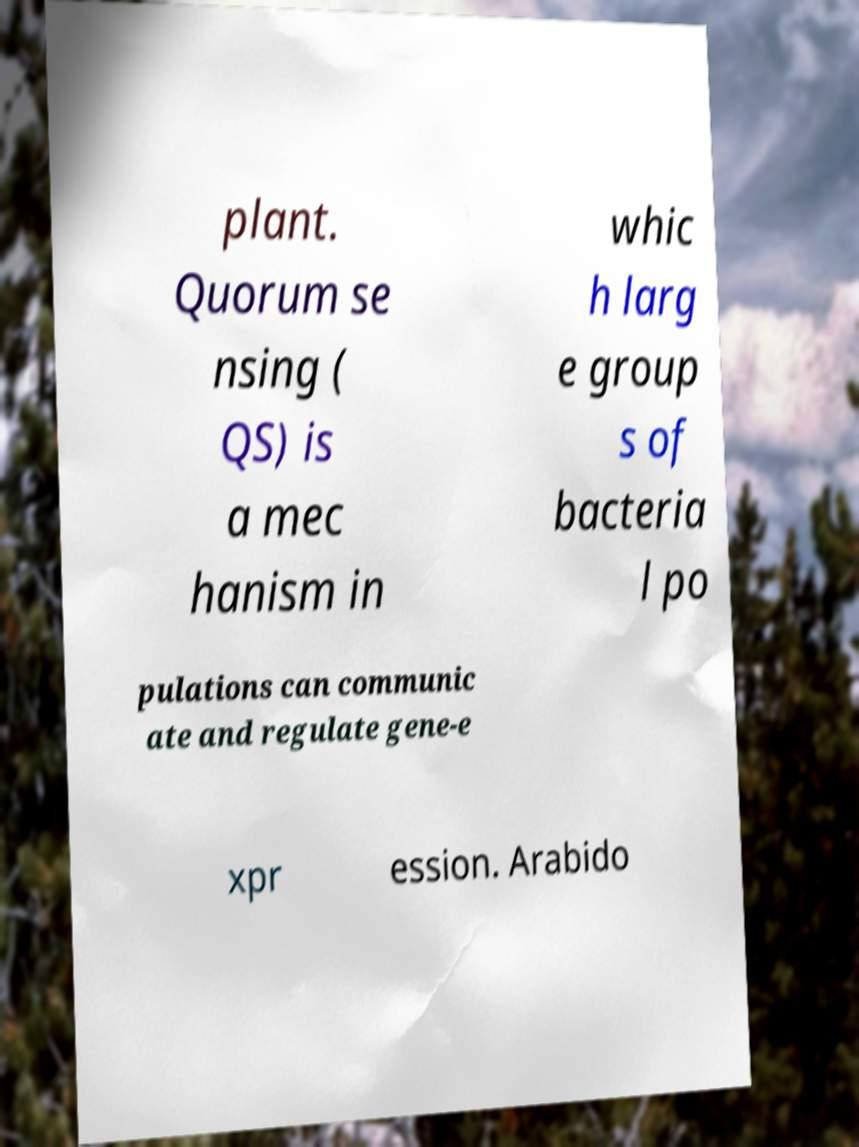Can you read and provide the text displayed in the image?This photo seems to have some interesting text. Can you extract and type it out for me? plant. Quorum se nsing ( QS) is a mec hanism in whic h larg e group s of bacteria l po pulations can communic ate and regulate gene-e xpr ession. Arabido 